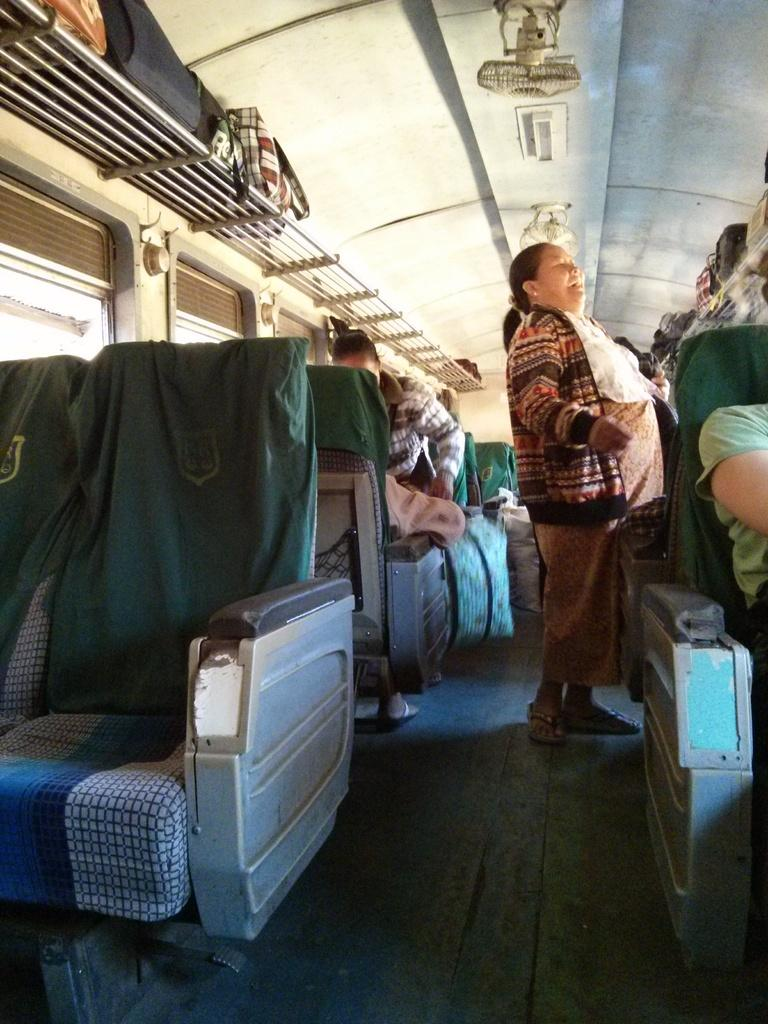What is the woman in the image doing? The woman is standing on the ground in the image. What are the people in the image doing? The people are sitting on chairs in the image. Where are the luggages located in the image? The luggages are kept on a rack in the image. Can you see the ocean in the image? No, there is no ocean visible in the image. What is the woman pushing in the image? There is no object being pushed by the woman in the image. 